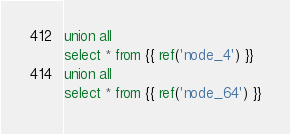Convert code to text. <code><loc_0><loc_0><loc_500><loc_500><_SQL_>union all
select * from {{ ref('node_4') }}
union all
select * from {{ ref('node_64') }}
</code> 